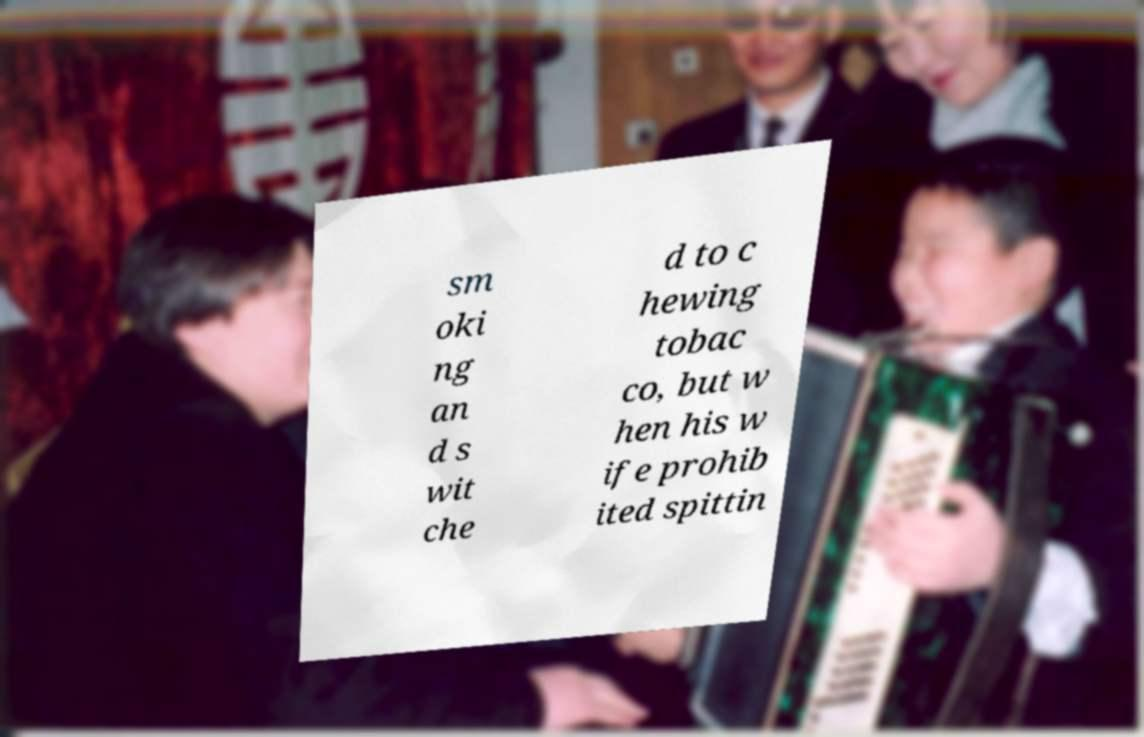Could you assist in decoding the text presented in this image and type it out clearly? sm oki ng an d s wit che d to c hewing tobac co, but w hen his w ife prohib ited spittin 